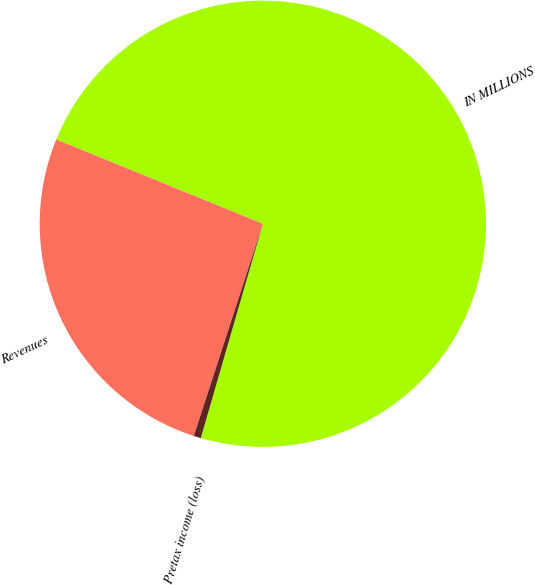<chart> <loc_0><loc_0><loc_500><loc_500><pie_chart><fcel>IN MILLIONS<fcel>Revenues<fcel>Pretax income (loss)<nl><fcel>73.33%<fcel>26.16%<fcel>0.52%<nl></chart> 